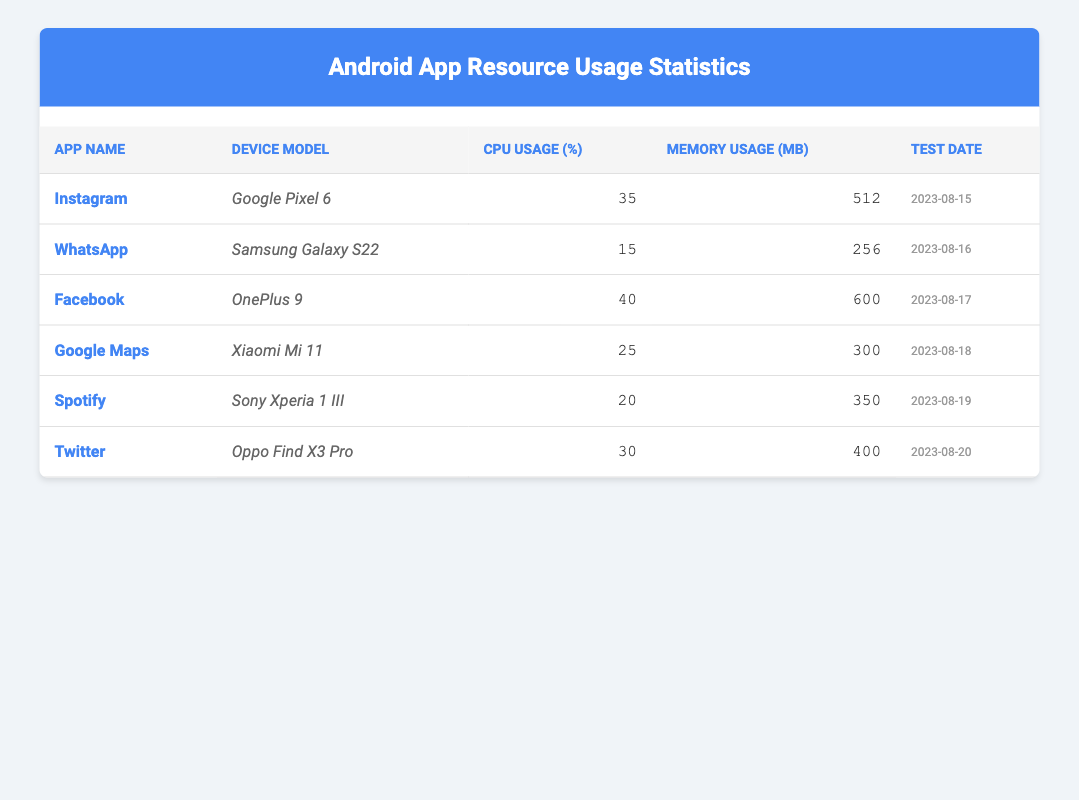What is the CPU usage percentage of Instagram on Google Pixel 6? The table lists the CPU usage percentage for Instagram under the relevant columns. For the "App Name" Instagram, the corresponding "CPU Usage (%)" is 35.
Answer: 35 Which app used the most memory? By examining the "Memory Usage (MB)" column, Facebook shows 600 MB, which is the highest among all listed apps.
Answer: Facebook What is the average CPU usage of all listed apps? To calculate the average CPU usage, add all the CPU usage percentages: (35 + 15 + 40 + 25 + 20 + 30) =  175. There are 6 apps, so the average is 175/6 = 29.17.
Answer: 29.17 Is the memory usage of Spotify less than that of Google Maps? The memory usage of Spotify is 350 MB, while Google Maps is 300 MB. Since 350 MB is greater than 300 MB, the answer is no.
Answer: No Which app has the lowest CPU usage and on what device was it tested? Upon reviewing the CPU usage percentages, WhatsApp has the lowest at 15%. The device on which it was tested is the Samsung Galaxy S22.
Answer: WhatsApp on Samsung Galaxy S22 How much more memory does Facebook use compared to Twitter? Facebook uses 600 MB and Twitter uses 400 MB. The difference is calculated by subtracting: 600 - 400 = 200 MB.
Answer: 200 MB Did any of the apps exceed 30% CPU usage? By scanning the "CPU Usage (%)" column, both Instagram (35%) and Facebook (40%) exceed 30%, so the answer is yes.
Answer: Yes Which app had the highest CPU usage and on which device? Facebook is identified as having the highest CPU usage at 40%, tested on OnePlus 9.
Answer: Facebook on OnePlus 9 